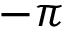<formula> <loc_0><loc_0><loc_500><loc_500>- \pi</formula> 